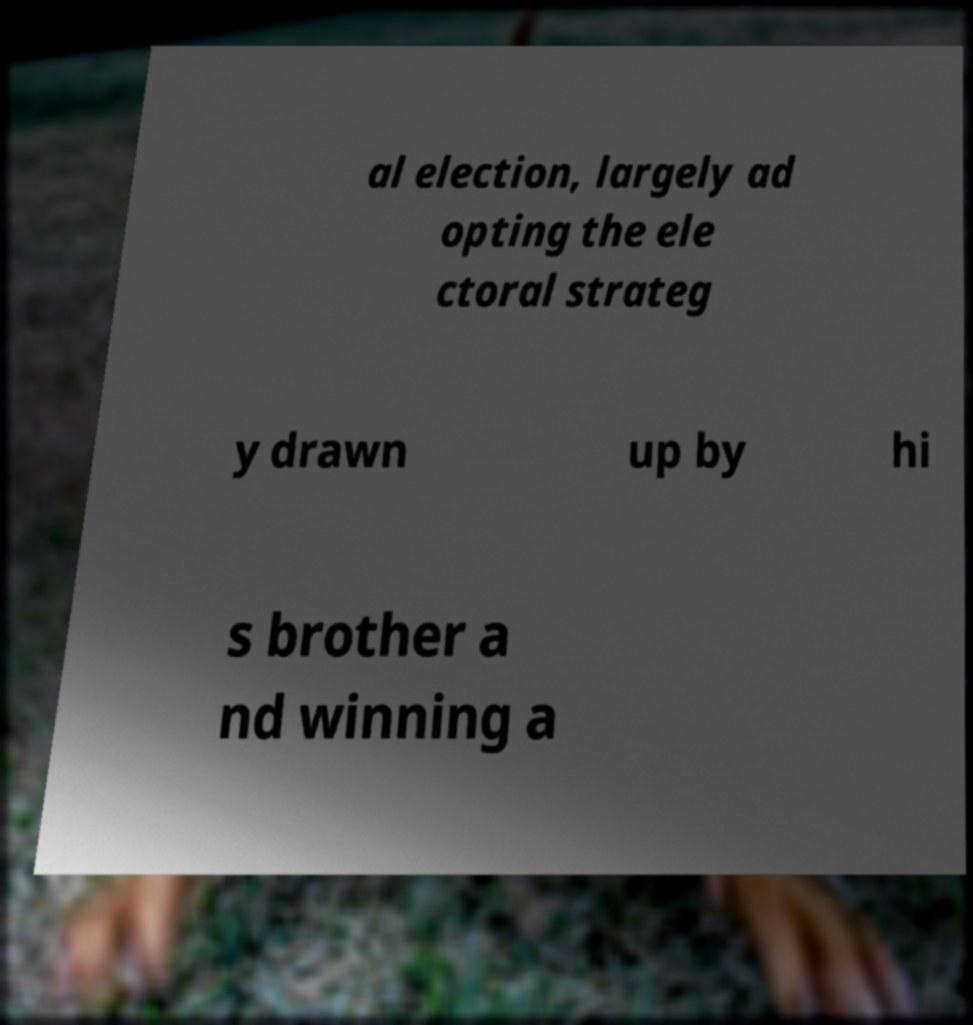Please read and relay the text visible in this image. What does it say? al election, largely ad opting the ele ctoral strateg y drawn up by hi s brother a nd winning a 